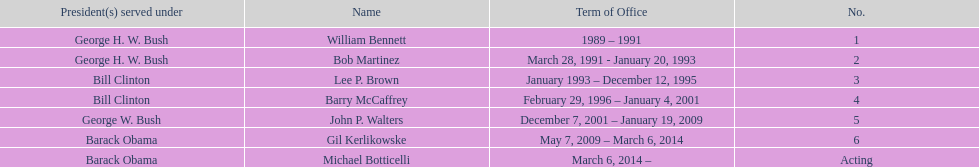What were the number of directors that stayed in office more than three years? 3. 